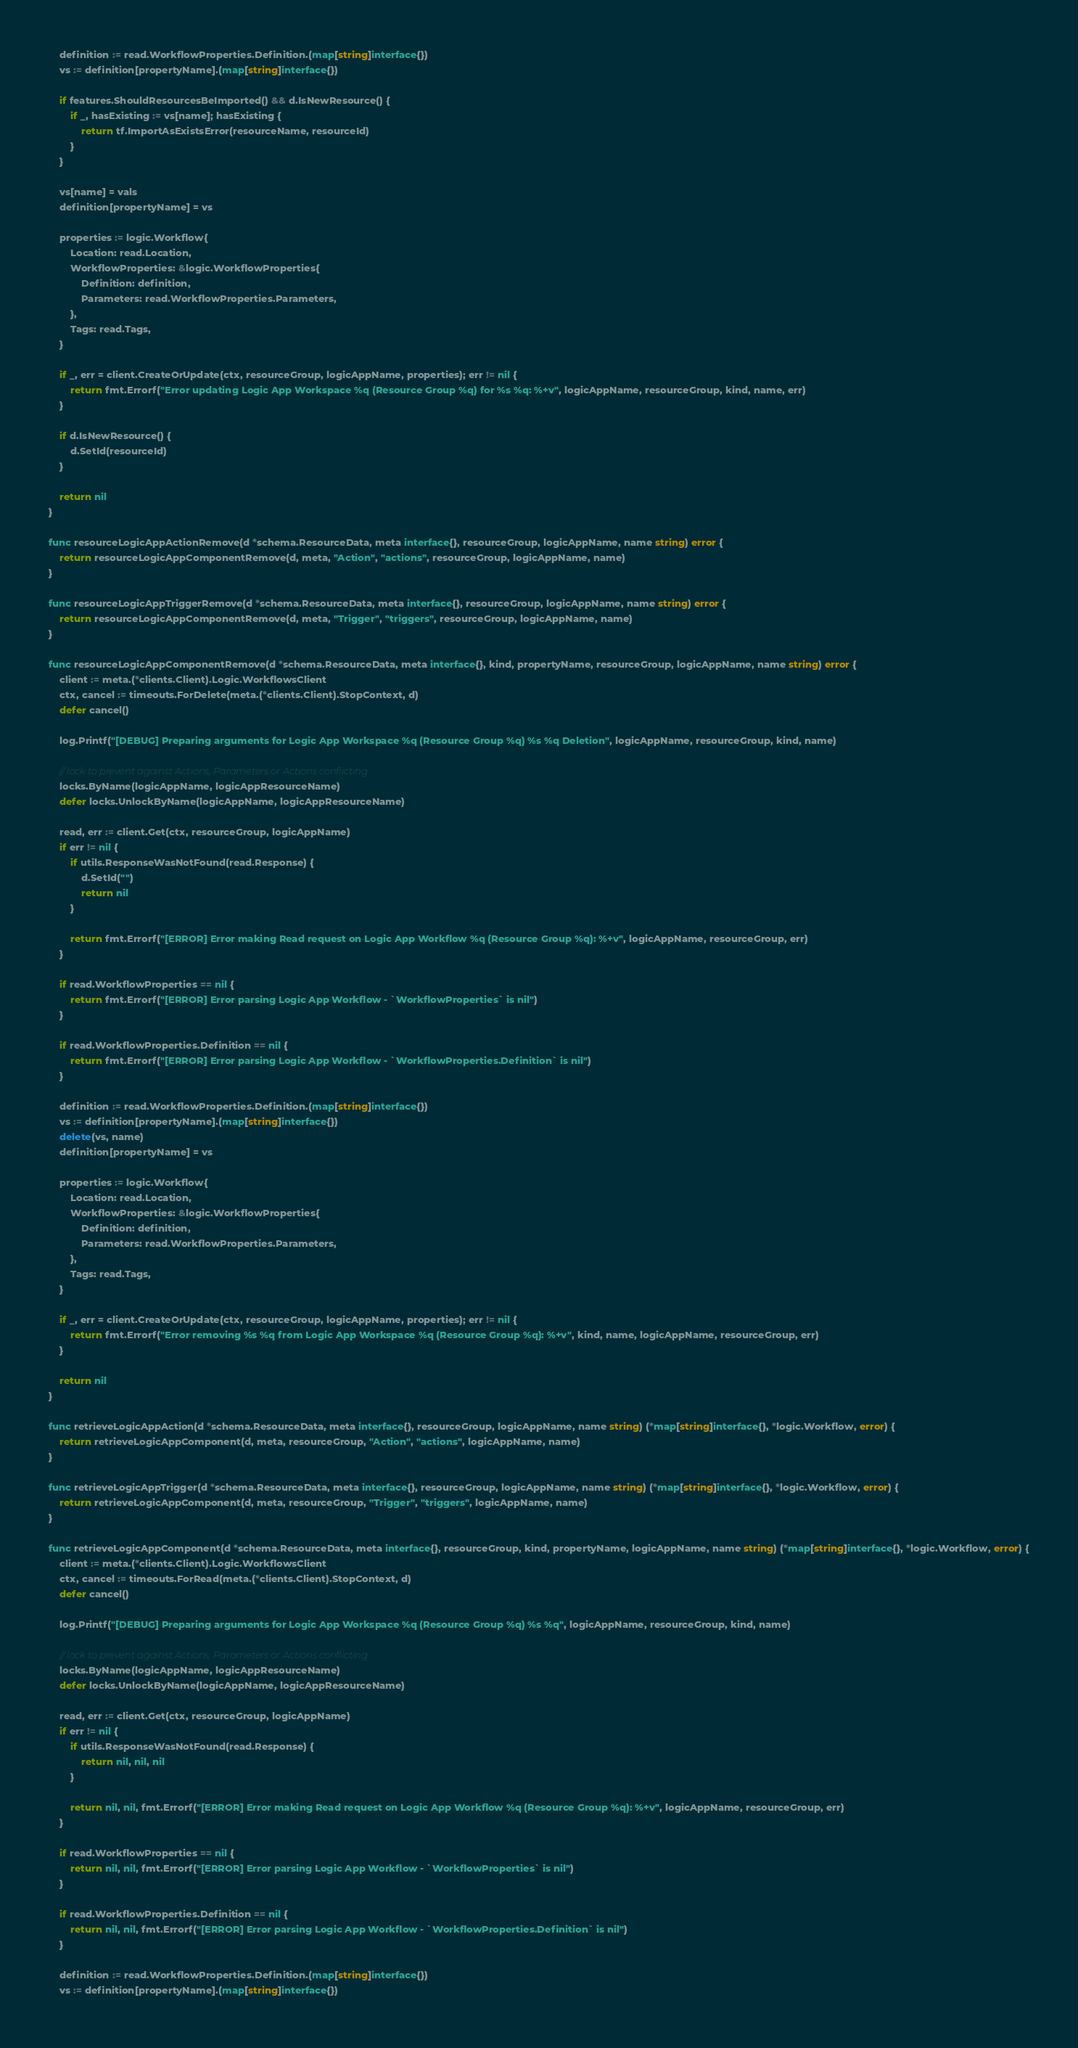Convert code to text. <code><loc_0><loc_0><loc_500><loc_500><_Go_>	definition := read.WorkflowProperties.Definition.(map[string]interface{})
	vs := definition[propertyName].(map[string]interface{})

	if features.ShouldResourcesBeImported() && d.IsNewResource() {
		if _, hasExisting := vs[name]; hasExisting {
			return tf.ImportAsExistsError(resourceName, resourceId)
		}
	}

	vs[name] = vals
	definition[propertyName] = vs

	properties := logic.Workflow{
		Location: read.Location,
		WorkflowProperties: &logic.WorkflowProperties{
			Definition: definition,
			Parameters: read.WorkflowProperties.Parameters,
		},
		Tags: read.Tags,
	}

	if _, err = client.CreateOrUpdate(ctx, resourceGroup, logicAppName, properties); err != nil {
		return fmt.Errorf("Error updating Logic App Workspace %q (Resource Group %q) for %s %q: %+v", logicAppName, resourceGroup, kind, name, err)
	}

	if d.IsNewResource() {
		d.SetId(resourceId)
	}

	return nil
}

func resourceLogicAppActionRemove(d *schema.ResourceData, meta interface{}, resourceGroup, logicAppName, name string) error {
	return resourceLogicAppComponentRemove(d, meta, "Action", "actions", resourceGroup, logicAppName, name)
}

func resourceLogicAppTriggerRemove(d *schema.ResourceData, meta interface{}, resourceGroup, logicAppName, name string) error {
	return resourceLogicAppComponentRemove(d, meta, "Trigger", "triggers", resourceGroup, logicAppName, name)
}

func resourceLogicAppComponentRemove(d *schema.ResourceData, meta interface{}, kind, propertyName, resourceGroup, logicAppName, name string) error {
	client := meta.(*clients.Client).Logic.WorkflowsClient
	ctx, cancel := timeouts.ForDelete(meta.(*clients.Client).StopContext, d)
	defer cancel()

	log.Printf("[DEBUG] Preparing arguments for Logic App Workspace %q (Resource Group %q) %s %q Deletion", logicAppName, resourceGroup, kind, name)

	// lock to prevent against Actions, Parameters or Actions conflicting
	locks.ByName(logicAppName, logicAppResourceName)
	defer locks.UnlockByName(logicAppName, logicAppResourceName)

	read, err := client.Get(ctx, resourceGroup, logicAppName)
	if err != nil {
		if utils.ResponseWasNotFound(read.Response) {
			d.SetId("")
			return nil
		}

		return fmt.Errorf("[ERROR] Error making Read request on Logic App Workflow %q (Resource Group %q): %+v", logicAppName, resourceGroup, err)
	}

	if read.WorkflowProperties == nil {
		return fmt.Errorf("[ERROR] Error parsing Logic App Workflow - `WorkflowProperties` is nil")
	}

	if read.WorkflowProperties.Definition == nil {
		return fmt.Errorf("[ERROR] Error parsing Logic App Workflow - `WorkflowProperties.Definition` is nil")
	}

	definition := read.WorkflowProperties.Definition.(map[string]interface{})
	vs := definition[propertyName].(map[string]interface{})
	delete(vs, name)
	definition[propertyName] = vs

	properties := logic.Workflow{
		Location: read.Location,
		WorkflowProperties: &logic.WorkflowProperties{
			Definition: definition,
			Parameters: read.WorkflowProperties.Parameters,
		},
		Tags: read.Tags,
	}

	if _, err = client.CreateOrUpdate(ctx, resourceGroup, logicAppName, properties); err != nil {
		return fmt.Errorf("Error removing %s %q from Logic App Workspace %q (Resource Group %q): %+v", kind, name, logicAppName, resourceGroup, err)
	}

	return nil
}

func retrieveLogicAppAction(d *schema.ResourceData, meta interface{}, resourceGroup, logicAppName, name string) (*map[string]interface{}, *logic.Workflow, error) {
	return retrieveLogicAppComponent(d, meta, resourceGroup, "Action", "actions", logicAppName, name)
}

func retrieveLogicAppTrigger(d *schema.ResourceData, meta interface{}, resourceGroup, logicAppName, name string) (*map[string]interface{}, *logic.Workflow, error) {
	return retrieveLogicAppComponent(d, meta, resourceGroup, "Trigger", "triggers", logicAppName, name)
}

func retrieveLogicAppComponent(d *schema.ResourceData, meta interface{}, resourceGroup, kind, propertyName, logicAppName, name string) (*map[string]interface{}, *logic.Workflow, error) {
	client := meta.(*clients.Client).Logic.WorkflowsClient
	ctx, cancel := timeouts.ForRead(meta.(*clients.Client).StopContext, d)
	defer cancel()

	log.Printf("[DEBUG] Preparing arguments for Logic App Workspace %q (Resource Group %q) %s %q", logicAppName, resourceGroup, kind, name)

	// lock to prevent against Actions, Parameters or Actions conflicting
	locks.ByName(logicAppName, logicAppResourceName)
	defer locks.UnlockByName(logicAppName, logicAppResourceName)

	read, err := client.Get(ctx, resourceGroup, logicAppName)
	if err != nil {
		if utils.ResponseWasNotFound(read.Response) {
			return nil, nil, nil
		}

		return nil, nil, fmt.Errorf("[ERROR] Error making Read request on Logic App Workflow %q (Resource Group %q): %+v", logicAppName, resourceGroup, err)
	}

	if read.WorkflowProperties == nil {
		return nil, nil, fmt.Errorf("[ERROR] Error parsing Logic App Workflow - `WorkflowProperties` is nil")
	}

	if read.WorkflowProperties.Definition == nil {
		return nil, nil, fmt.Errorf("[ERROR] Error parsing Logic App Workflow - `WorkflowProperties.Definition` is nil")
	}

	definition := read.WorkflowProperties.Definition.(map[string]interface{})
	vs := definition[propertyName].(map[string]interface{})</code> 